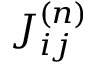Convert formula to latex. <formula><loc_0><loc_0><loc_500><loc_500>J _ { i j } ^ { ( n ) }</formula> 